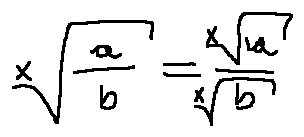Convert formula to latex. <formula><loc_0><loc_0><loc_500><loc_500>\sqrt { [ } x ] { \frac { a } { b } } = \frac { \sqrt { [ } x ] { a } } { \sqrt { [ } x ] { b } }</formula> 